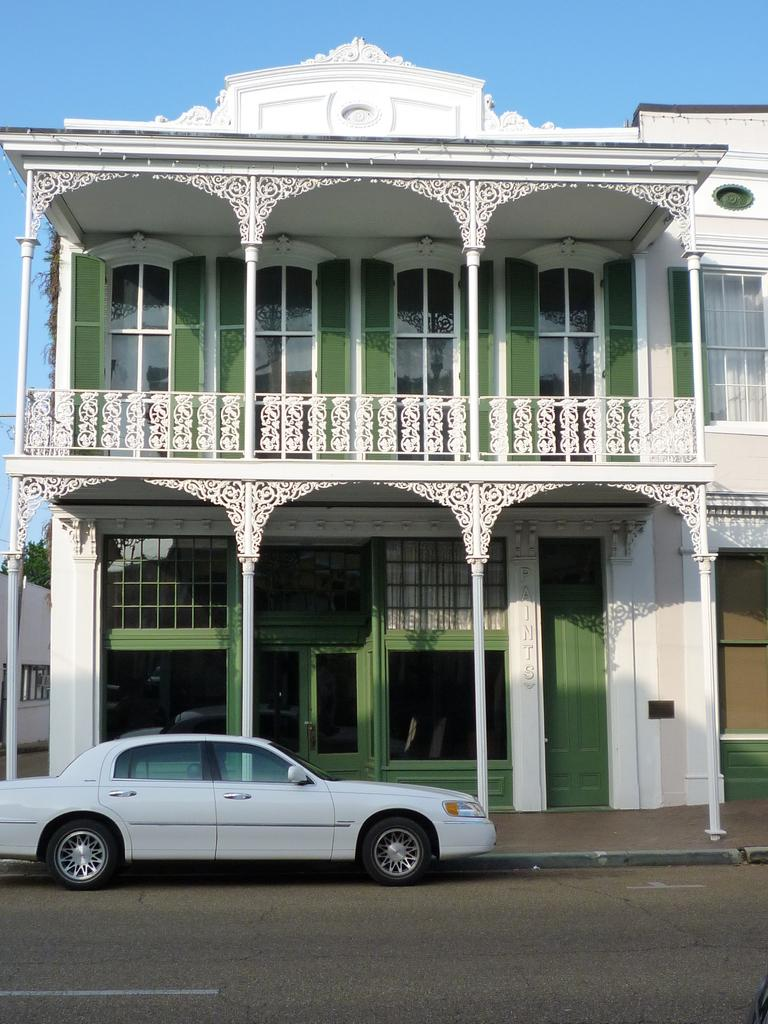What type of structure is present in the image? There is a building in the image. What can be seen on the road in front of the building? A car is visible on the road in front of the building. What part of the natural environment is visible in the image? The sky is visible above the building. What type of metal is used to form the car in the image? The image does not provide information about the type of metal used to form the car, nor does it show the car's construction. 